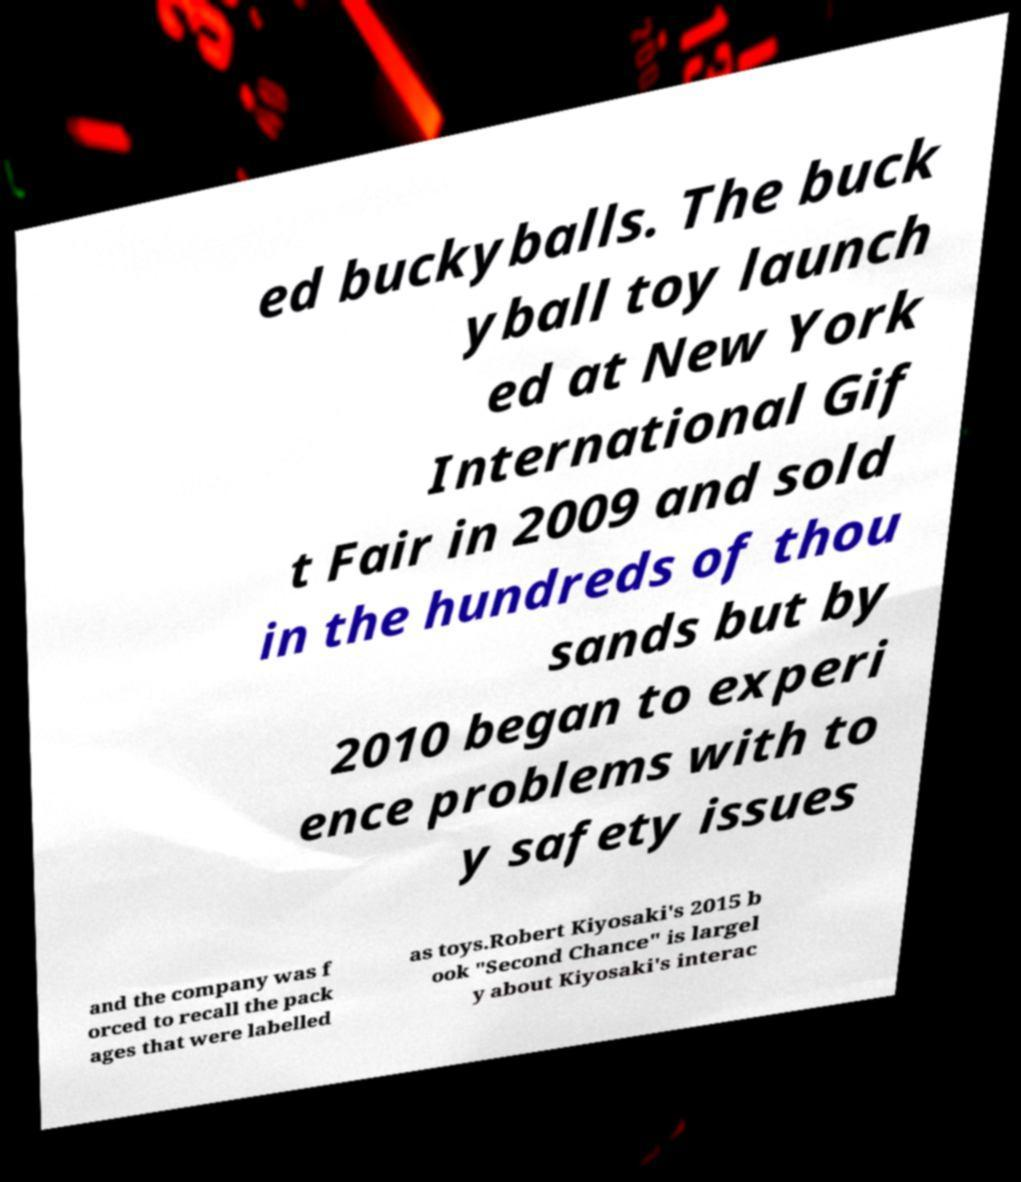Please identify and transcribe the text found in this image. ed buckyballs. The buck yball toy launch ed at New York International Gif t Fair in 2009 and sold in the hundreds of thou sands but by 2010 began to experi ence problems with to y safety issues and the company was f orced to recall the pack ages that were labelled as toys.Robert Kiyosaki's 2015 b ook "Second Chance" is largel y about Kiyosaki's interac 